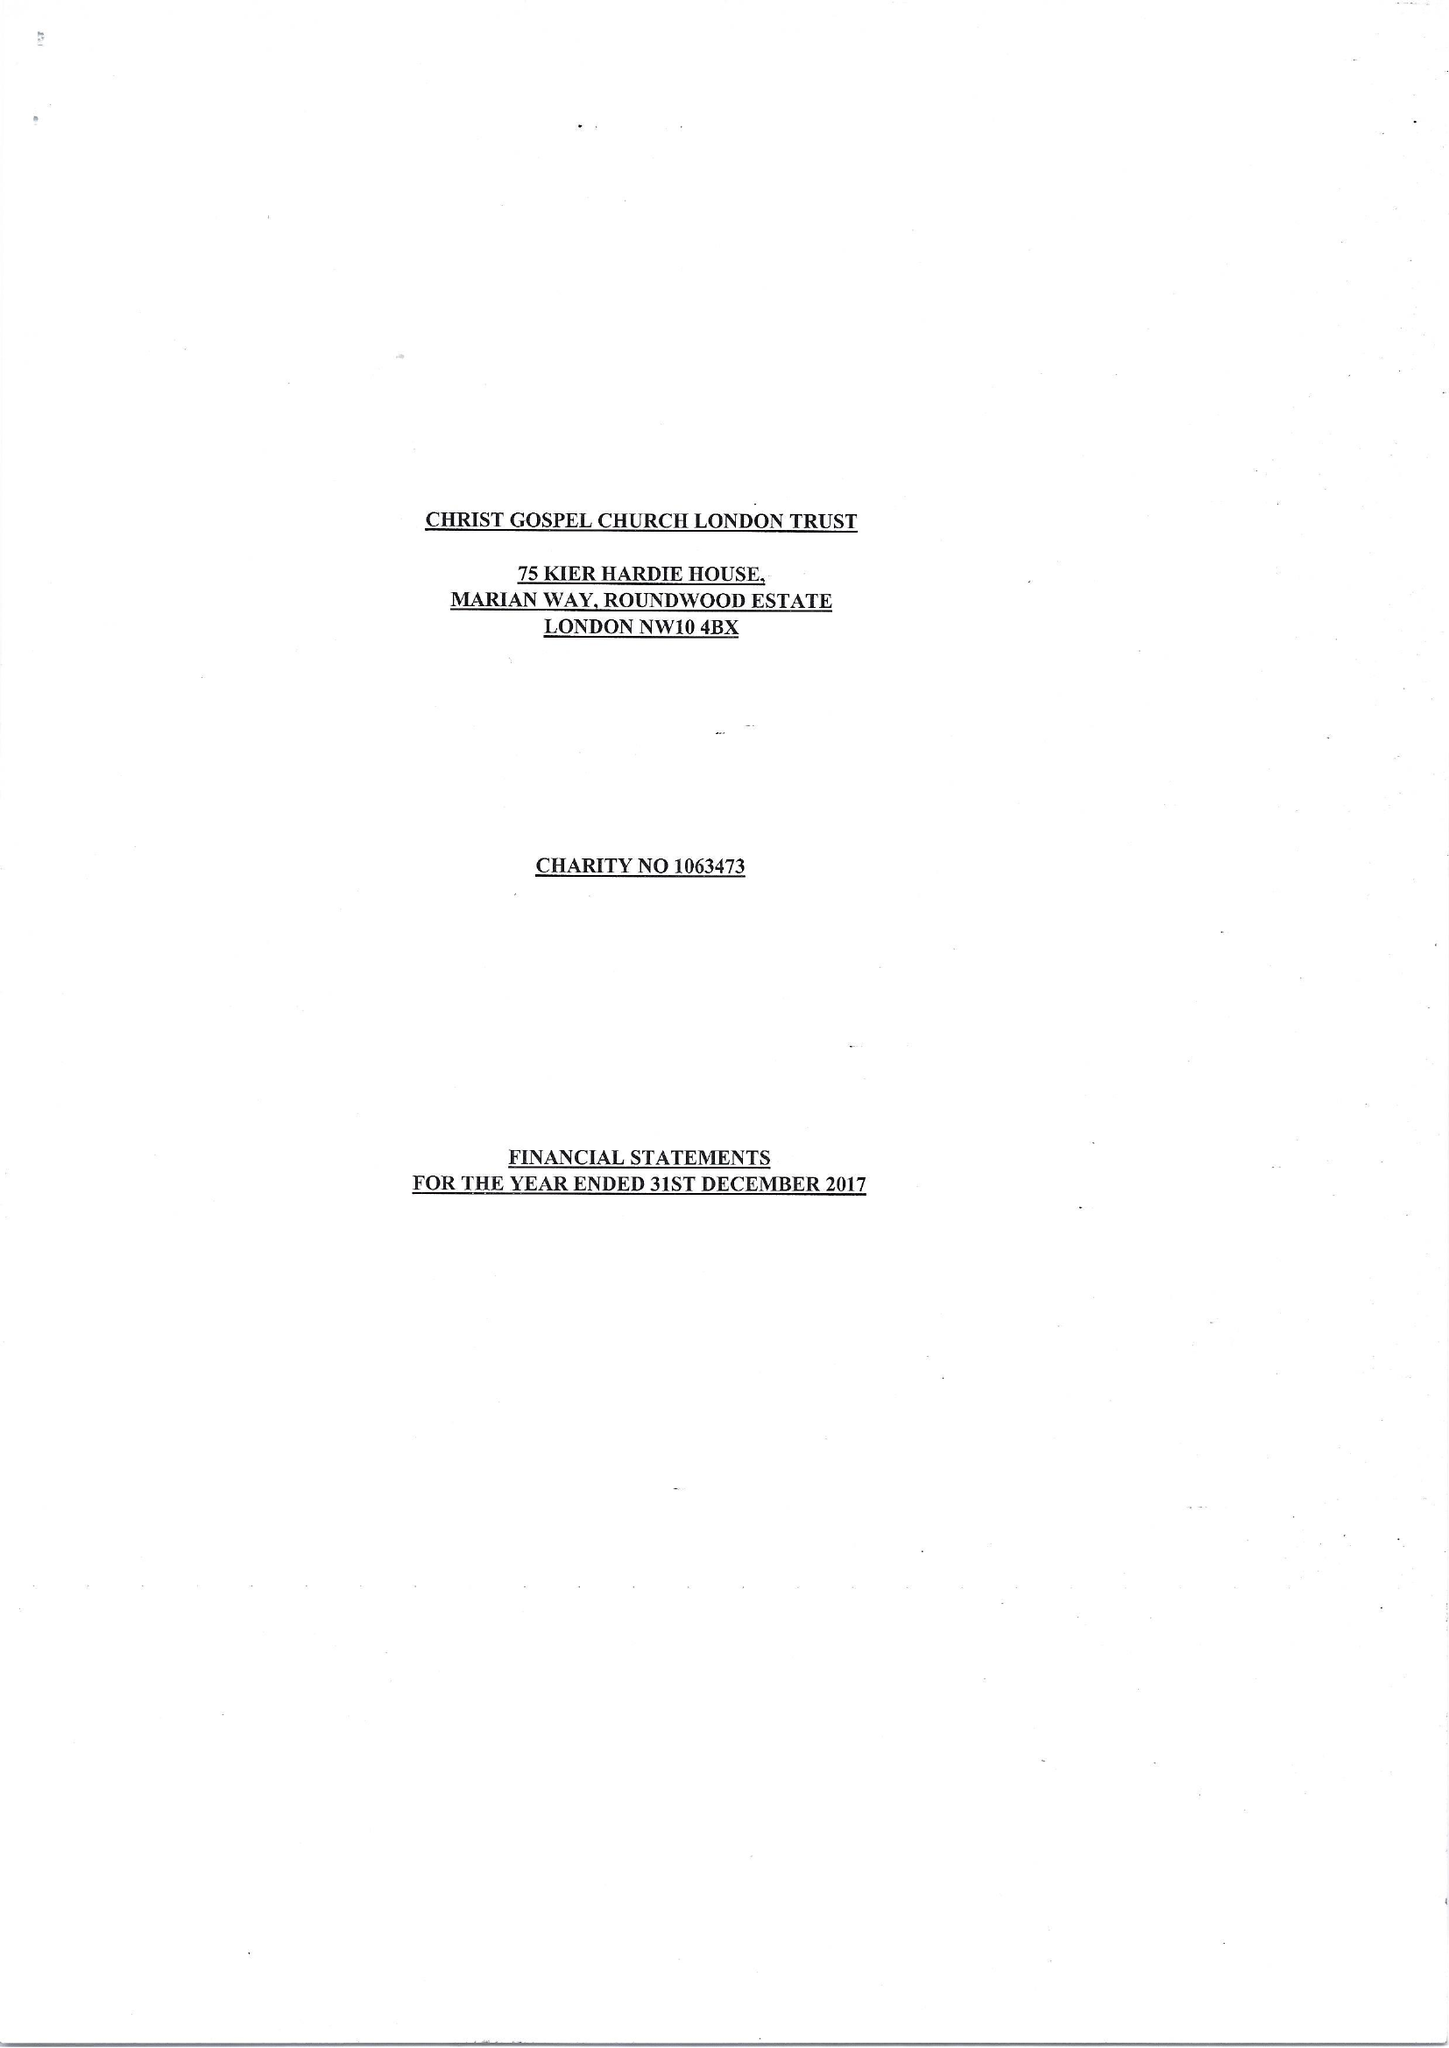What is the value for the report_date?
Answer the question using a single word or phrase. 2017-12-31 